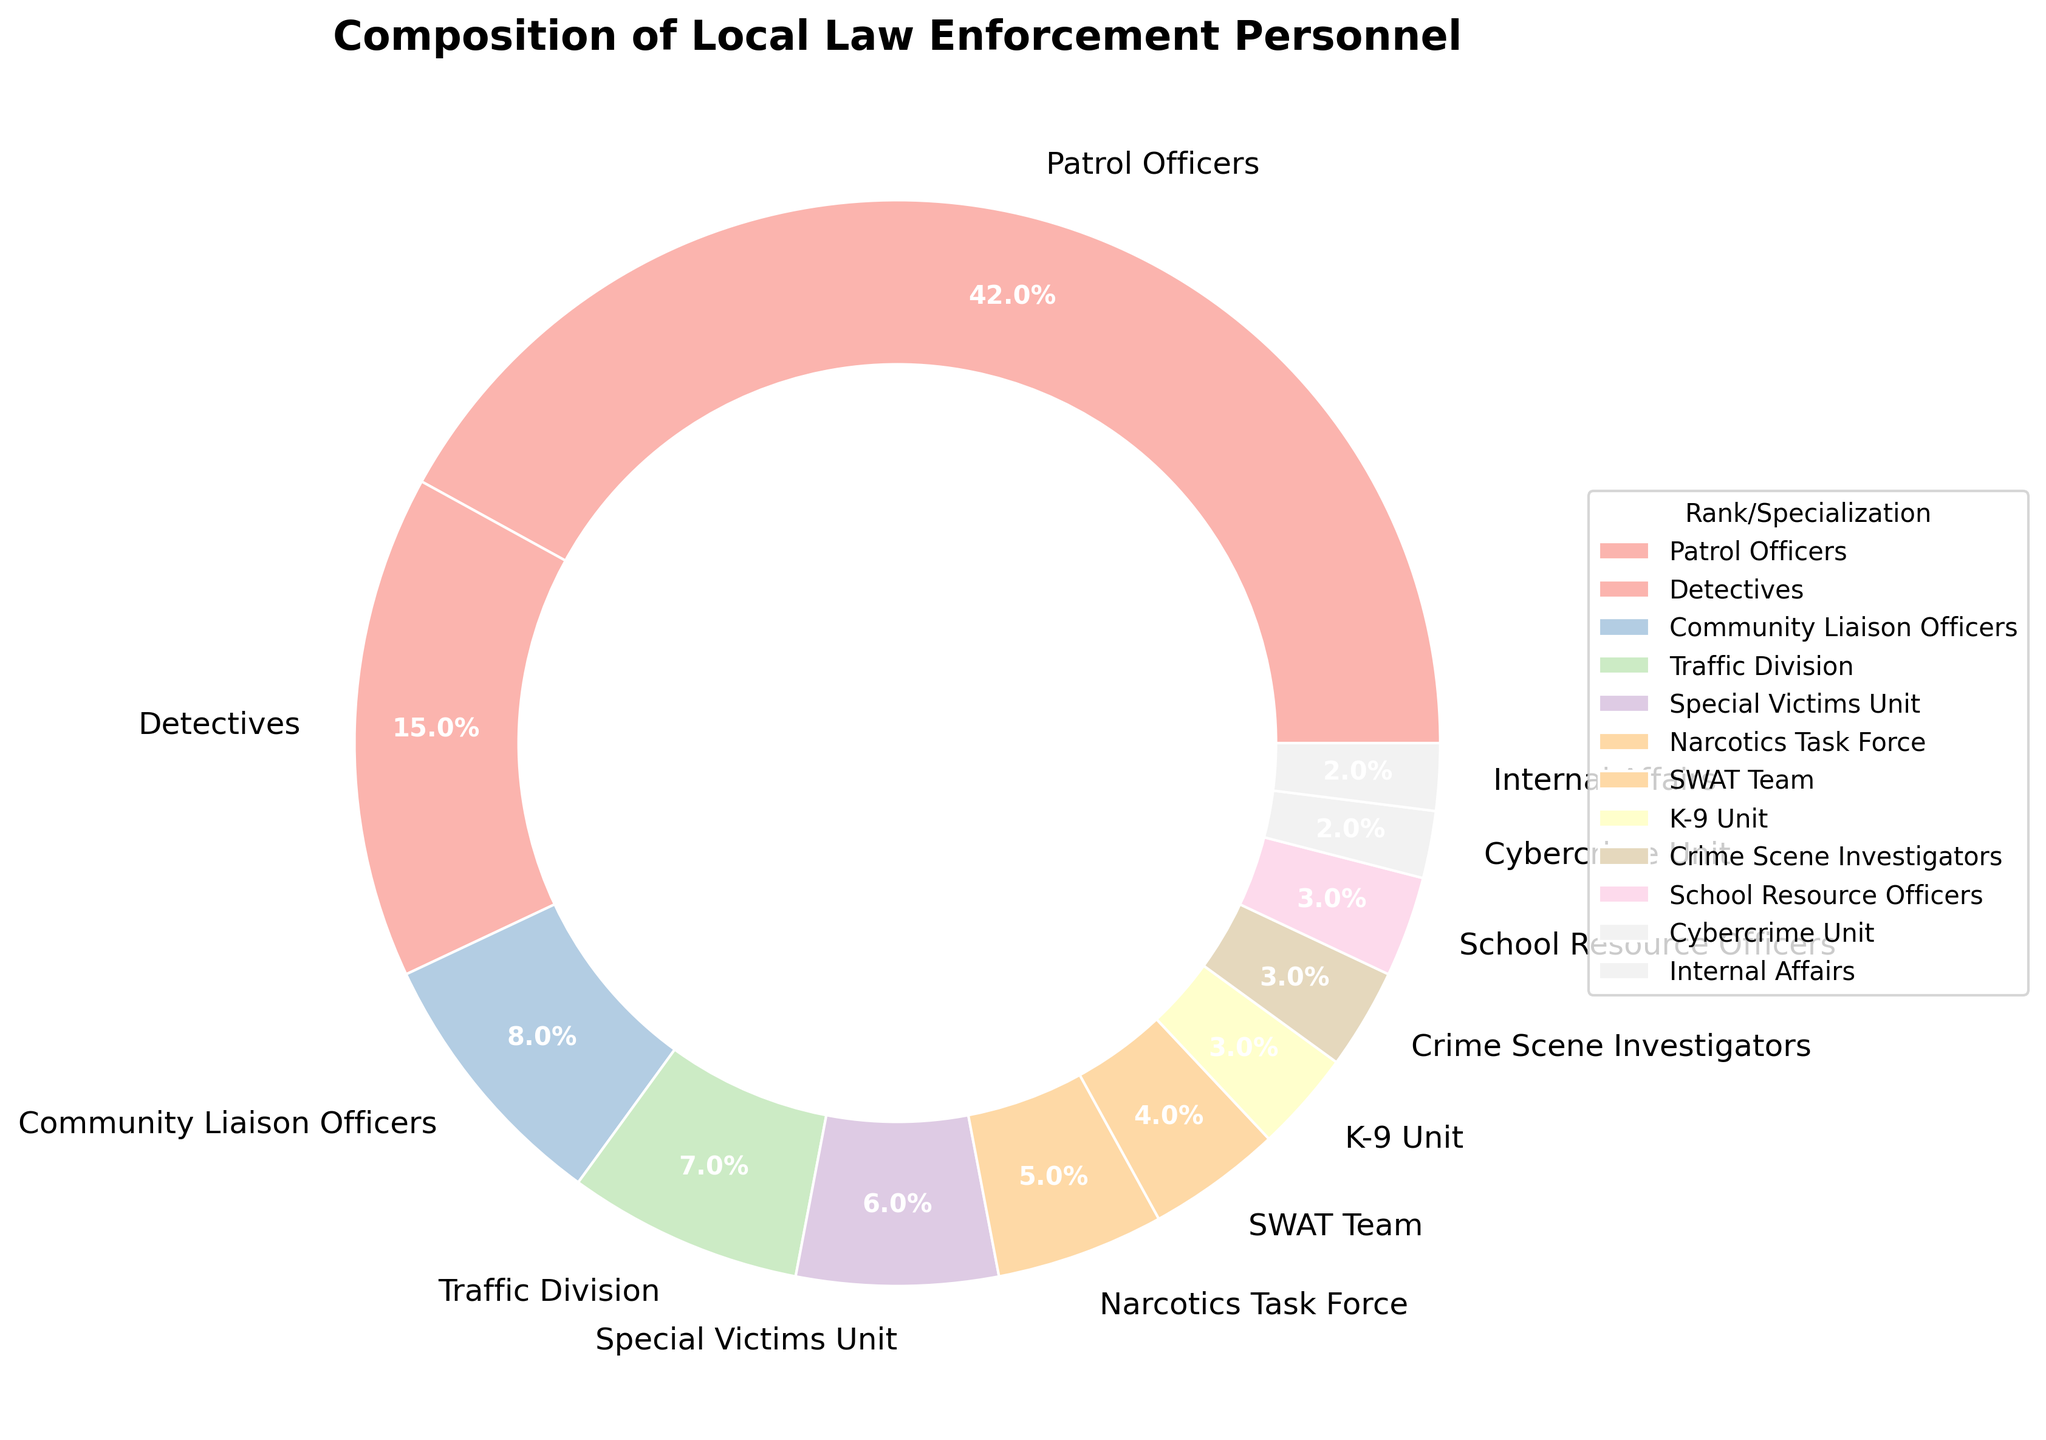What percentage of local law enforcement personnel are Patrol Officers? Look for the section labeled "Patrol Officers" in the pie chart and note the percentage displayed alongside it.
Answer: 42% Which unit has a higher percentage, Detectives or Narcotics Task Force? Compare the two sections labeled "Detectives" and "Narcotics Task Force" and see which has the greater percentage.
Answer: Detectives How much more is the percentage of Patrol Officers compared to School Resource Officers? Find the percentage values for Patrol Officers and School Resource Officers, then subtract the percentage of School Resource Officers from Patrol Officers (42% - 3%).
Answer: 39% What is the combined percentage of Special Victims Unit and Cybercrime Unit? Add the percentage values for Special Victims Unit (6%) and Cybercrime Unit (2%) together (6% + 2%).
Answer: 8% Is the percentage of K-9 Unit personnel greater than or equal to that of the Crime Scene Investigators? Compare the percentage values for K-9 Unit and Crime Scene Investigators. K-9 Unit has 3%, and Crime Scene Investigators also have 3%.
Answer: Yes Which three categories have the smallest percentages? Identify the sections with the smallest percentages. The Cybercrime Unit, Internal Affairs, and K-9 Unit each occupy the smallest parts of the pie chart.
Answer: Cybercrime Unit, Internal Affairs, K-9 Unit How does the percentage of community-focused roles (Community Liaison Officers and School Resource Officers) compare to the entire law enforcement composition? Add the percentages of Community Liaison Officers (8%) and School Resource Officers (3%). Then divide by the total percentage (which is 100%) to find the combined percentage within the total composition (8% + 3%) / 100%.
Answer: 11% What is the difference in percentage between the Traffic Division and SWAT Team? Subtract the percentage of the SWAT Team (4%) from the Traffic Division's percentage (7%) (7% - 4%).
Answer: 3% Which section occupies the largest part of the pie chart? Identify the section with the highest percentage. This is clearly labeled and visually the largest section in the pie chart.
Answer: Patrol Officers Are there more Traffic Division personnel than Special Victims Unit personnel? Compare the percentage values for Traffic Division (7%) and Special Victims Unit (6%).
Answer: Yes 